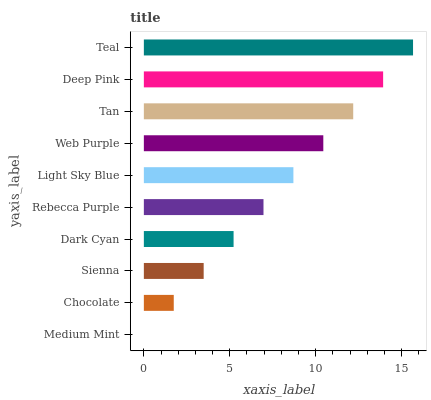Is Medium Mint the minimum?
Answer yes or no. Yes. Is Teal the maximum?
Answer yes or no. Yes. Is Chocolate the minimum?
Answer yes or no. No. Is Chocolate the maximum?
Answer yes or no. No. Is Chocolate greater than Medium Mint?
Answer yes or no. Yes. Is Medium Mint less than Chocolate?
Answer yes or no. Yes. Is Medium Mint greater than Chocolate?
Answer yes or no. No. Is Chocolate less than Medium Mint?
Answer yes or no. No. Is Light Sky Blue the high median?
Answer yes or no. Yes. Is Rebecca Purple the low median?
Answer yes or no. Yes. Is Deep Pink the high median?
Answer yes or no. No. Is Chocolate the low median?
Answer yes or no. No. 